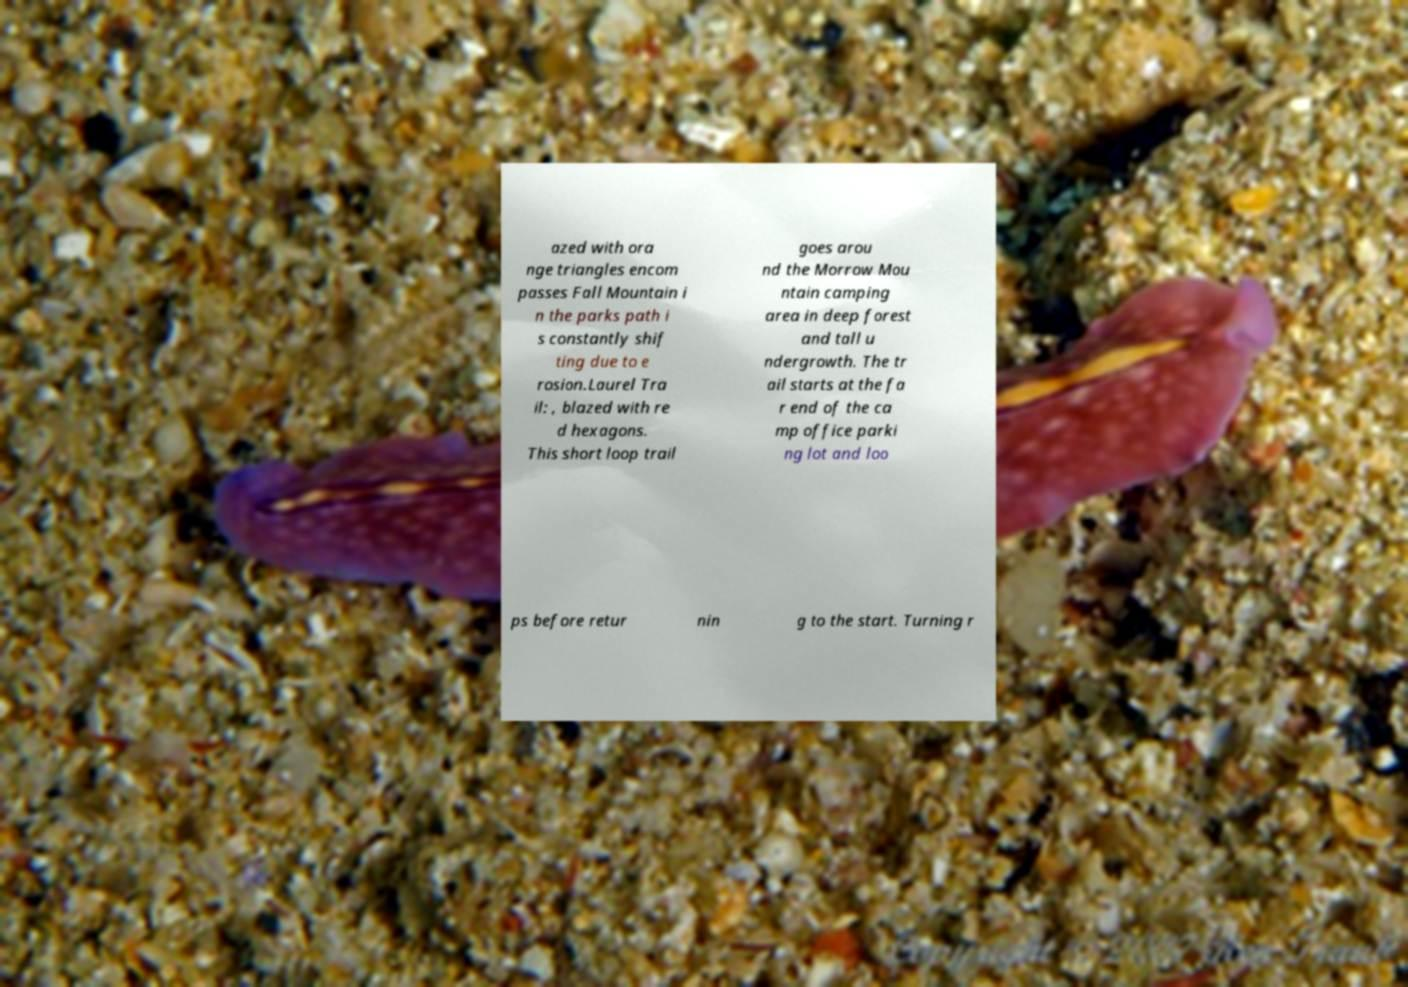For documentation purposes, I need the text within this image transcribed. Could you provide that? azed with ora nge triangles encom passes Fall Mountain i n the parks path i s constantly shif ting due to e rosion.Laurel Tra il: , blazed with re d hexagons. This short loop trail goes arou nd the Morrow Mou ntain camping area in deep forest and tall u ndergrowth. The tr ail starts at the fa r end of the ca mp office parki ng lot and loo ps before retur nin g to the start. Turning r 